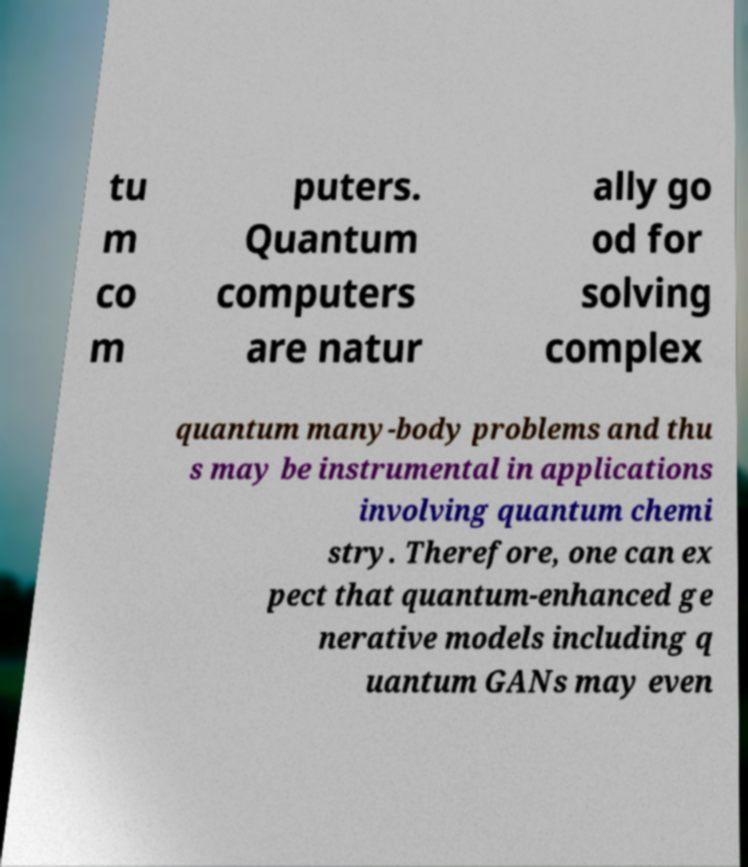For documentation purposes, I need the text within this image transcribed. Could you provide that? tu m co m puters. Quantum computers are natur ally go od for solving complex quantum many-body problems and thu s may be instrumental in applications involving quantum chemi stry. Therefore, one can ex pect that quantum-enhanced ge nerative models including q uantum GANs may even 